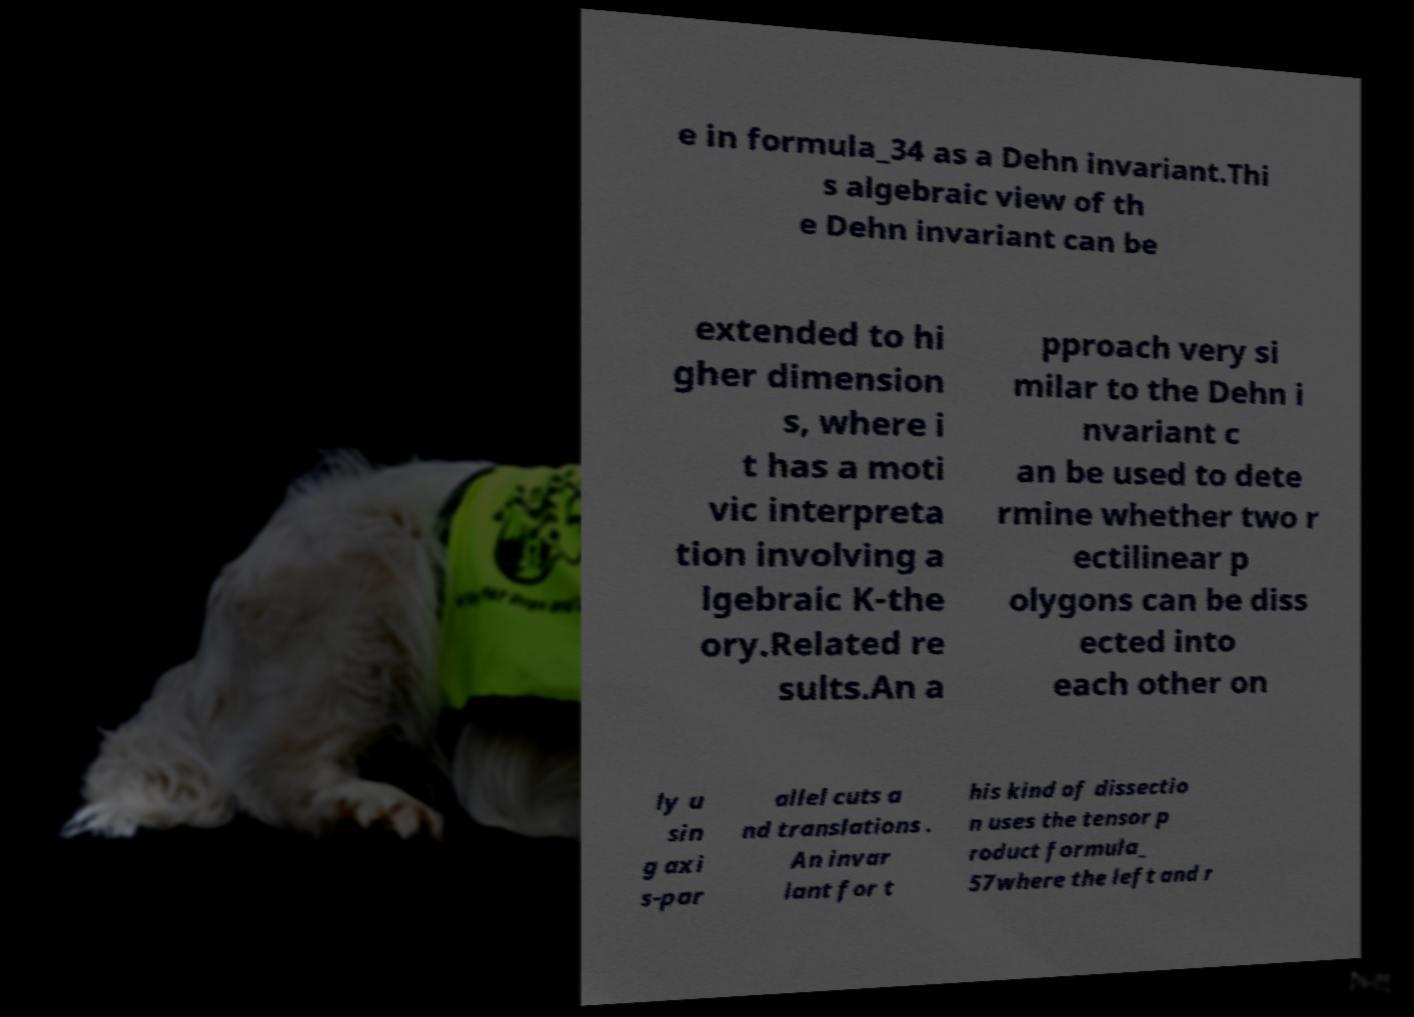Can you read and provide the text displayed in the image?This photo seems to have some interesting text. Can you extract and type it out for me? e in formula_34 as a Dehn invariant.Thi s algebraic view of th e Dehn invariant can be extended to hi gher dimension s, where i t has a moti vic interpreta tion involving a lgebraic K-the ory.Related re sults.An a pproach very si milar to the Dehn i nvariant c an be used to dete rmine whether two r ectilinear p olygons can be diss ected into each other on ly u sin g axi s-par allel cuts a nd translations . An invar iant for t his kind of dissectio n uses the tensor p roduct formula_ 57where the left and r 